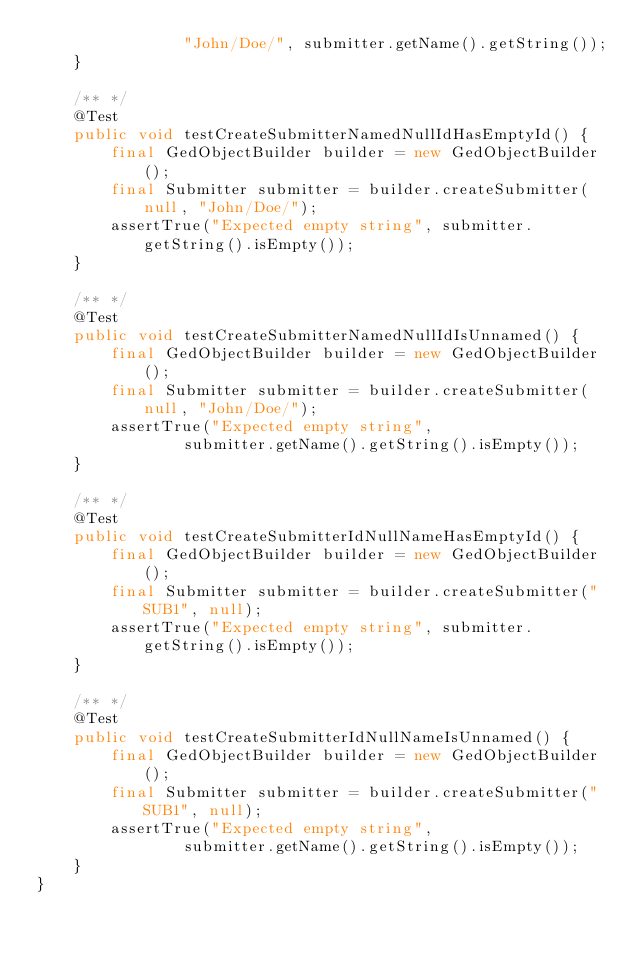Convert code to text. <code><loc_0><loc_0><loc_500><loc_500><_Java_>                "John/Doe/", submitter.getName().getString());
    }

    /** */
    @Test
    public void testCreateSubmitterNamedNullIdHasEmptyId() {
        final GedObjectBuilder builder = new GedObjectBuilder();
        final Submitter submitter = builder.createSubmitter(null, "John/Doe/");
        assertTrue("Expected empty string", submitter.getString().isEmpty());
    }

    /** */
    @Test
    public void testCreateSubmitterNamedNullIdIsUnnamed() {
        final GedObjectBuilder builder = new GedObjectBuilder();
        final Submitter submitter = builder.createSubmitter(null, "John/Doe/");
        assertTrue("Expected empty string",
                submitter.getName().getString().isEmpty());
    }

    /** */
    @Test
    public void testCreateSubmitterIdNullNameHasEmptyId() {
        final GedObjectBuilder builder = new GedObjectBuilder();
        final Submitter submitter = builder.createSubmitter("SUB1", null);
        assertTrue("Expected empty string", submitter.getString().isEmpty());
    }

    /** */
    @Test
    public void testCreateSubmitterIdNullNameIsUnnamed() {
        final GedObjectBuilder builder = new GedObjectBuilder();
        final Submitter submitter = builder.createSubmitter("SUB1", null);
        assertTrue("Expected empty string",
                submitter.getName().getString().isEmpty());
    }
}
</code> 